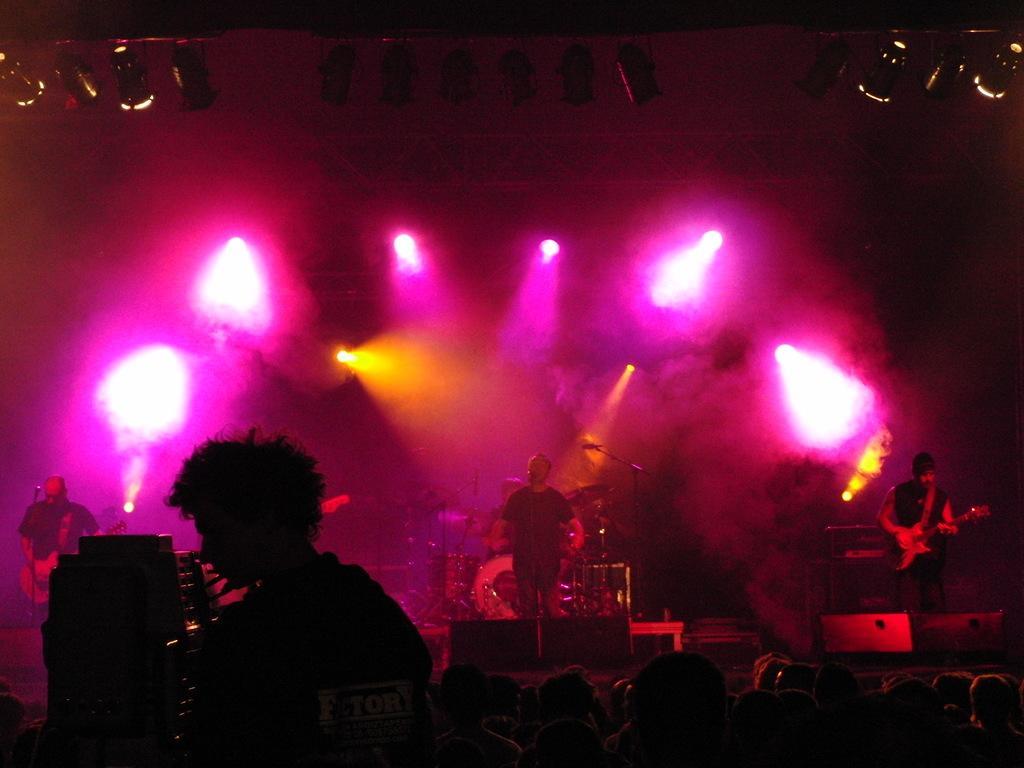How would you summarize this image in a sentence or two? In this picture we can see a group of people standing on the floor and the other people on the stage who are holding some musical instruments and playing it. 